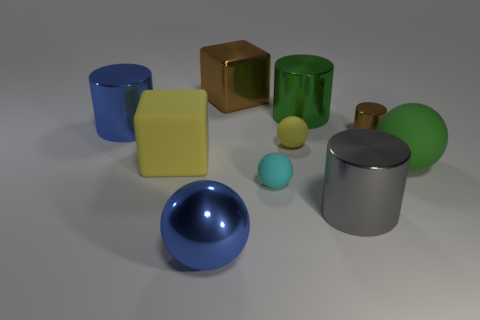Subtract all cubes. How many objects are left? 8 Add 9 small red matte cylinders. How many small red matte cylinders exist? 9 Subtract 1 cyan spheres. How many objects are left? 9 Subtract all brown shiny things. Subtract all large green spheres. How many objects are left? 7 Add 6 big metal cylinders. How many big metal cylinders are left? 9 